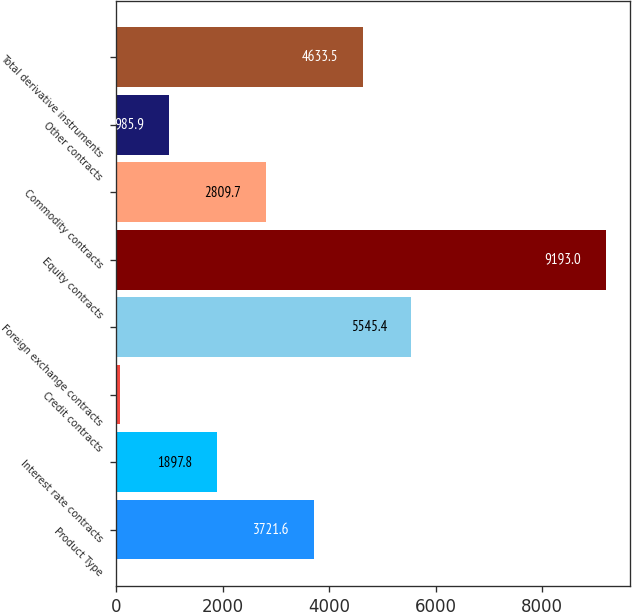Convert chart to OTSL. <chart><loc_0><loc_0><loc_500><loc_500><bar_chart><fcel>Product Type<fcel>Interest rate contracts<fcel>Credit contracts<fcel>Foreign exchange contracts<fcel>Equity contracts<fcel>Commodity contracts<fcel>Other contracts<fcel>Total derivative instruments<nl><fcel>3721.6<fcel>1897.8<fcel>74<fcel>5545.4<fcel>9193<fcel>2809.7<fcel>985.9<fcel>4633.5<nl></chart> 